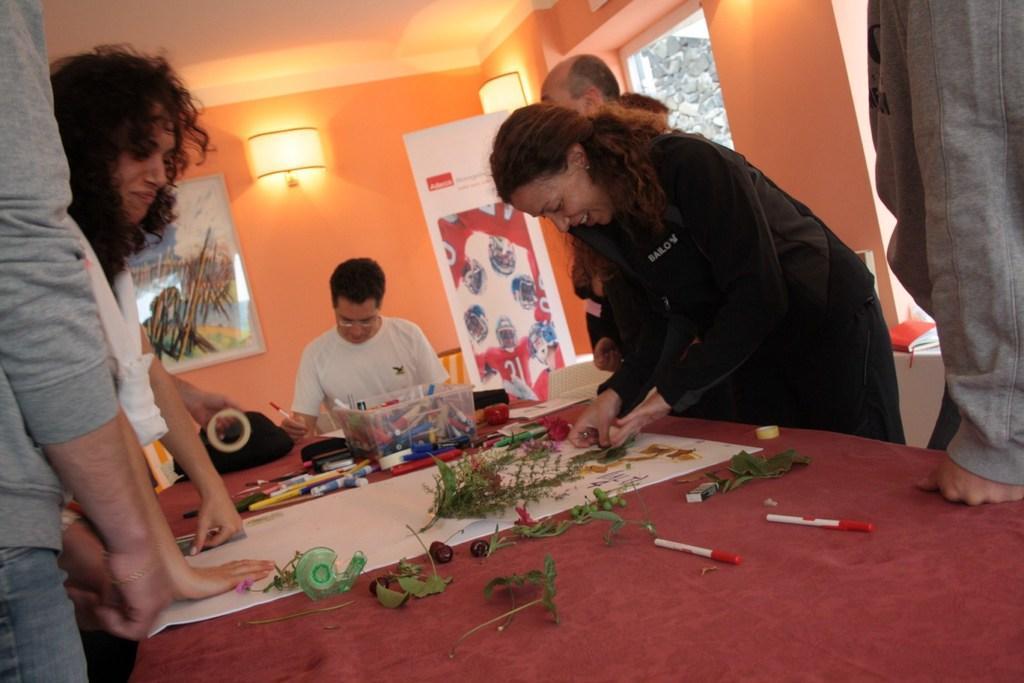In one or two sentences, can you explain what this image depicts? On the left hand side, there are two persons standing. In front of them, there are leaves, sheet, sketches, box and other items on the table which is covered with red color cloth. On the right hand side, some other people are standing. In the background, there is a person in white color shirt sitting and writing, there is orange color wall, light, poster on the wall and a poster. 